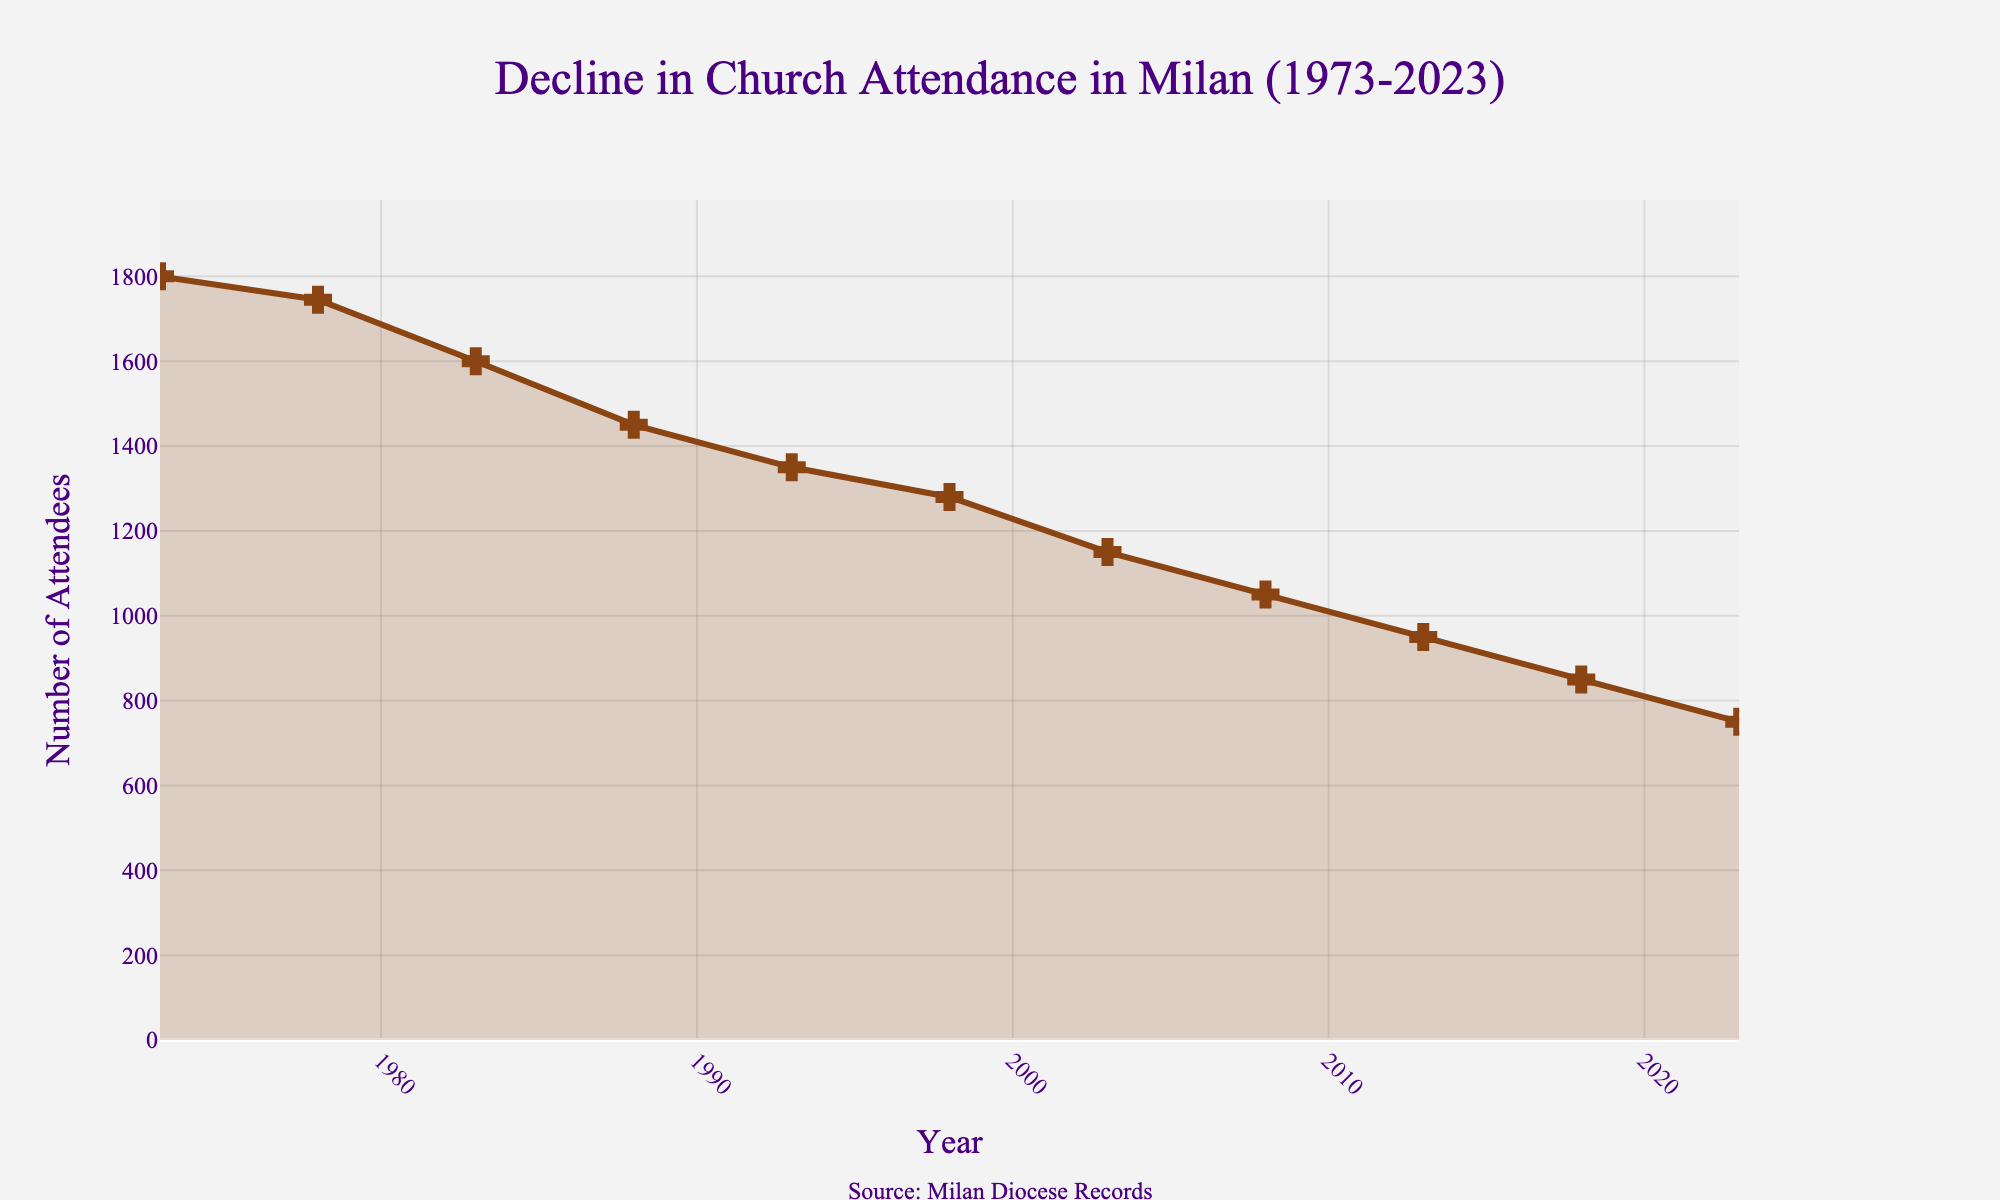How many years are represented in the figure? The x-axis of the figure spans from 1973 to 2023. To count the number of years, subtract the starting year (1973) from the ending year (2023) and add 1 to include both the start and end years. So, (2023 - 1973 + 1) = 51 years.
Answer: 51 What is the highest church attendance recorded? The highest point on the y-axis marks the church attendance value in the year 1973, which is 1800 attendees.
Answer: 1800 In which year did the church attendance drop below 1000 for the first time? Following the trend line downwards from the highest to the lowest values, church attendance first drops below 1000 in the year 2018.
Answer: 2018 What is the average church attendance in the years represented? To find the average, sum all the church attendance values and divide by the number of years. Total is (1800 + 1745 + 1600 + 1450 + 1350 + 1280 + 1150 + 1050 + 950 + 850 + 750) = 13975, and there are 11 years. So, average is 13975 / 11 ≈ 1270.45.
Answer: 1270.45 Which decade saw the greatest decline in church attendance? To determine the greatest decline, compare the differences in church attendance in each decade: 1973-1983 is (1800-1600)=200, 1983-1993 is (1600-1350)=250, 1993-2003 is (1350-1150)=200, 2003-2023 is (1150-750)=400. The decade 2003-2023 saw the greatest decline of 400 attendees.
Answer: 2003-2023 By what percentage did church attendance decline from 1973 to 2023? To find the percentage decline, subtract the 2023 attendance from the 1973 attendance, divide by the 1973 attendance and multiply by 100. ((1800-750) / 1800) * 100 ≈ 58.33%.
Answer: 58.33% Which year experienced the smallest decrease in church attendance compared to the previous recorded year? To find the smallest decrease year-over-year, calculate the differences: 1973-1978 is 55, 1978-1983 is 145, 1983-1988 is 150, 1988-1993 is 100, 1993-1998 is 70, 1998-2003 is 130, 2003-2008 is 100, 2008-2013 is 100, 2013-2018 is 100, 2018-2023 is 100. The years 1973-1978 had the smallest decline of 55 attendees.
Answer: 1973-1978 Compare the church attendance in 1983 to 2003. By how much did it decrease? Attendance in 1983 was 1600 and in 2003 it was 1150. To find the decrease, subtract the 2003 attendance from 1983 attendance: 1600 - 1150 = 450.
Answer: 450 How are the changes in church attendance visualized in the plot? The changes are shown using a line with markers on a time series plot, where the x-axis represents years and the y-axis shows the number of attendees. The line connects these points to illustrate the trend over time.
Answer: line with markers Are there any annotations or additional texts on the figure? What do they say? Yes, there is an annotation at the bottom of the plot that reads "Source: Milan Diocese Records".
Answer: Source: Milan Diocese Records 